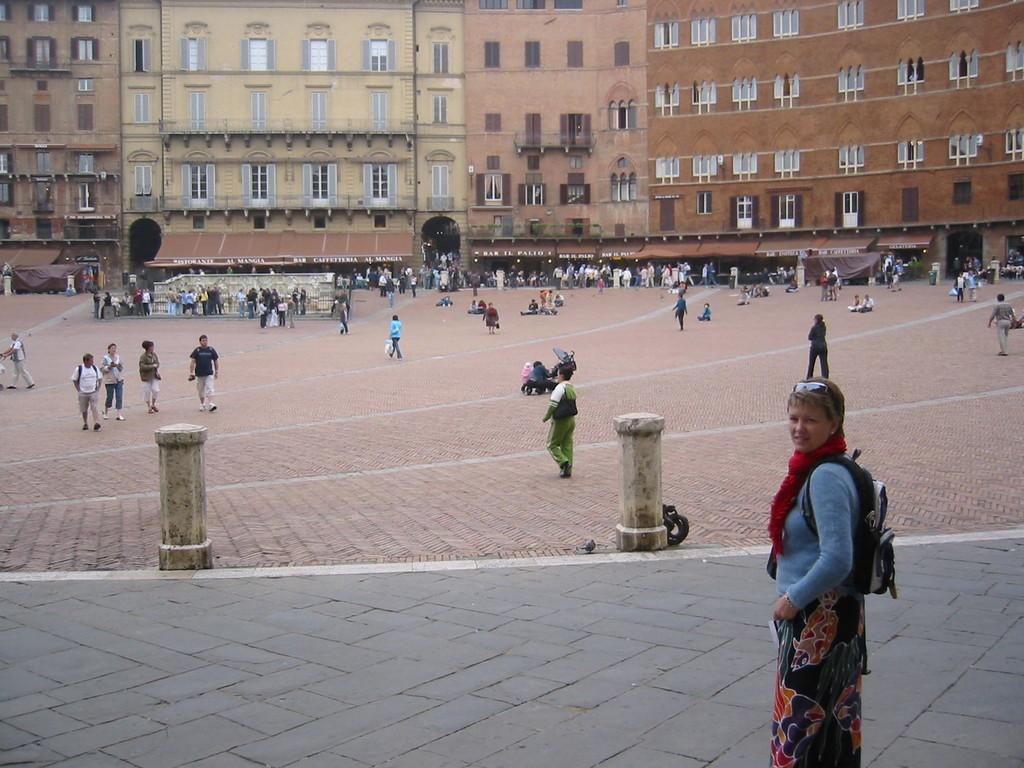How many persons are visible in the image? There are persons standing in the image. What surface are the persons standing on? The persons are standing on the floor. What can be seen in the background of the image? There are buildings, windows, and iron grills in the background of the image. What type of advice can be seen on the shelf in the image? There is no shelf present in the image, so no advice can be seen. 